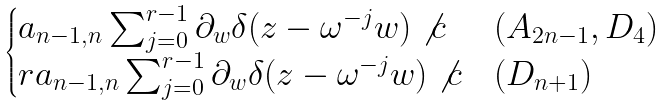Convert formula to latex. <formula><loc_0><loc_0><loc_500><loc_500>\begin{cases} a _ { n - 1 , n } \sum _ { j = 0 } ^ { r - 1 } \partial _ { w } \delta ( z - \omega ^ { - j } w ) \not { c } & ( A _ { 2 n - 1 } , D _ { 4 } ) \\ r a _ { n - 1 , n } \sum _ { j = 0 } ^ { r - 1 } \partial _ { w } \delta ( z - \omega ^ { - j } w ) \not { c } & ( D _ { n + 1 } ) \end{cases}</formula> 